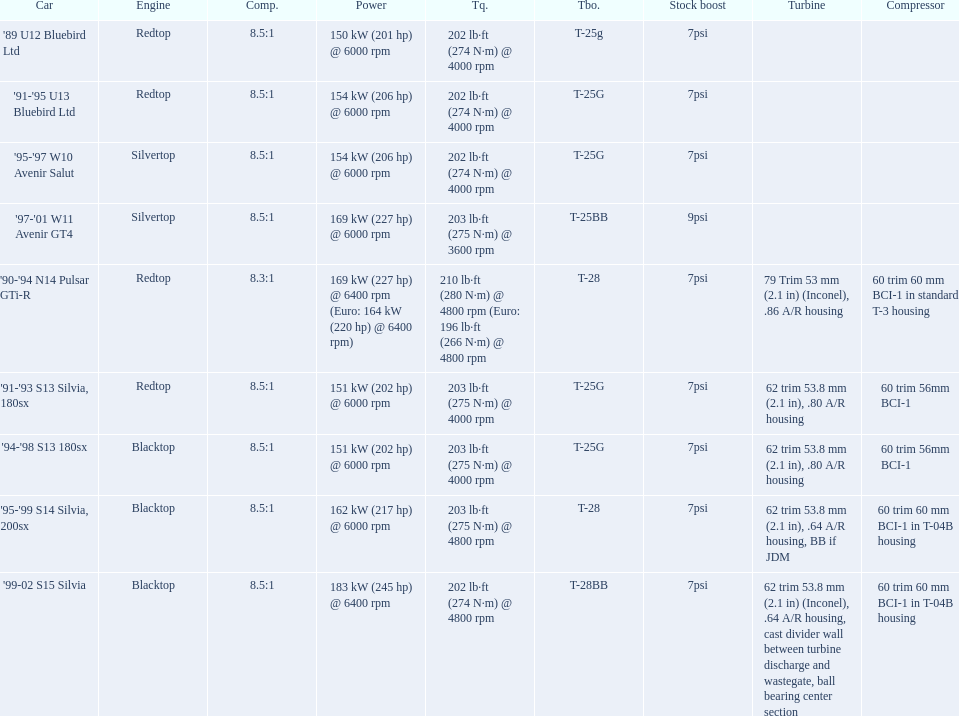Parse the full table in json format. {'header': ['Car', 'Engine', 'Comp.', 'Power', 'Tq.', 'Tbo.', 'Stock boost', 'Turbine', 'Compressor'], 'rows': [["'89 U12 Bluebird Ltd", 'Redtop', '8.5:1', '150\xa0kW (201\xa0hp) @ 6000 rpm', '202\xa0lb·ft (274\xa0N·m) @ 4000 rpm', 'T-25g', '7psi', '', ''], ["'91-'95 U13 Bluebird Ltd", 'Redtop', '8.5:1', '154\xa0kW (206\xa0hp) @ 6000 rpm', '202\xa0lb·ft (274\xa0N·m) @ 4000 rpm', 'T-25G', '7psi', '', ''], ["'95-'97 W10 Avenir Salut", 'Silvertop', '8.5:1', '154\xa0kW (206\xa0hp) @ 6000 rpm', '202\xa0lb·ft (274\xa0N·m) @ 4000 rpm', 'T-25G', '7psi', '', ''], ["'97-'01 W11 Avenir GT4", 'Silvertop', '8.5:1', '169\xa0kW (227\xa0hp) @ 6000 rpm', '203\xa0lb·ft (275\xa0N·m) @ 3600 rpm', 'T-25BB', '9psi', '', ''], ["'90-'94 N14 Pulsar GTi-R", 'Redtop', '8.3:1', '169\xa0kW (227\xa0hp) @ 6400 rpm (Euro: 164\xa0kW (220\xa0hp) @ 6400 rpm)', '210\xa0lb·ft (280\xa0N·m) @ 4800 rpm (Euro: 196\xa0lb·ft (266\xa0N·m) @ 4800 rpm', 'T-28', '7psi', '79 Trim 53\xa0mm (2.1\xa0in) (Inconel), .86 A/R housing', '60 trim 60\xa0mm BCI-1 in standard T-3 housing'], ["'91-'93 S13 Silvia, 180sx", 'Redtop', '8.5:1', '151\xa0kW (202\xa0hp) @ 6000 rpm', '203\xa0lb·ft (275\xa0N·m) @ 4000 rpm', 'T-25G', '7psi', '62 trim 53.8\xa0mm (2.1\xa0in), .80 A/R housing', '60 trim 56mm BCI-1'], ["'94-'98 S13 180sx", 'Blacktop', '8.5:1', '151\xa0kW (202\xa0hp) @ 6000 rpm', '203\xa0lb·ft (275\xa0N·m) @ 4000 rpm', 'T-25G', '7psi', '62 trim 53.8\xa0mm (2.1\xa0in), .80 A/R housing', '60 trim 56mm BCI-1'], ["'95-'99 S14 Silvia, 200sx", 'Blacktop', '8.5:1', '162\xa0kW (217\xa0hp) @ 6000 rpm', '203\xa0lb·ft (275\xa0N·m) @ 4800 rpm', 'T-28', '7psi', '62 trim 53.8\xa0mm (2.1\xa0in), .64 A/R housing, BB if JDM', '60 trim 60\xa0mm BCI-1 in T-04B housing'], ["'99-02 S15 Silvia", 'Blacktop', '8.5:1', '183\xa0kW (245\xa0hp) @ 6400 rpm', '202\xa0lb·ft (274\xa0N·m) @ 4800 rpm', 'T-28BB', '7psi', '62 trim 53.8\xa0mm (2.1\xa0in) (Inconel), .64 A/R housing, cast divider wall between turbine discharge and wastegate, ball bearing center section', '60 trim 60\xa0mm BCI-1 in T-04B housing']]} What are all of the cars? '89 U12 Bluebird Ltd, '91-'95 U13 Bluebird Ltd, '95-'97 W10 Avenir Salut, '97-'01 W11 Avenir GT4, '90-'94 N14 Pulsar GTi-R, '91-'93 S13 Silvia, 180sx, '94-'98 S13 180sx, '95-'99 S14 Silvia, 200sx, '99-02 S15 Silvia. What is their rated power? 150 kW (201 hp) @ 6000 rpm, 154 kW (206 hp) @ 6000 rpm, 154 kW (206 hp) @ 6000 rpm, 169 kW (227 hp) @ 6000 rpm, 169 kW (227 hp) @ 6400 rpm (Euro: 164 kW (220 hp) @ 6400 rpm), 151 kW (202 hp) @ 6000 rpm, 151 kW (202 hp) @ 6000 rpm, 162 kW (217 hp) @ 6000 rpm, 183 kW (245 hp) @ 6400 rpm. Which car has the most power? '99-02 S15 Silvia. 